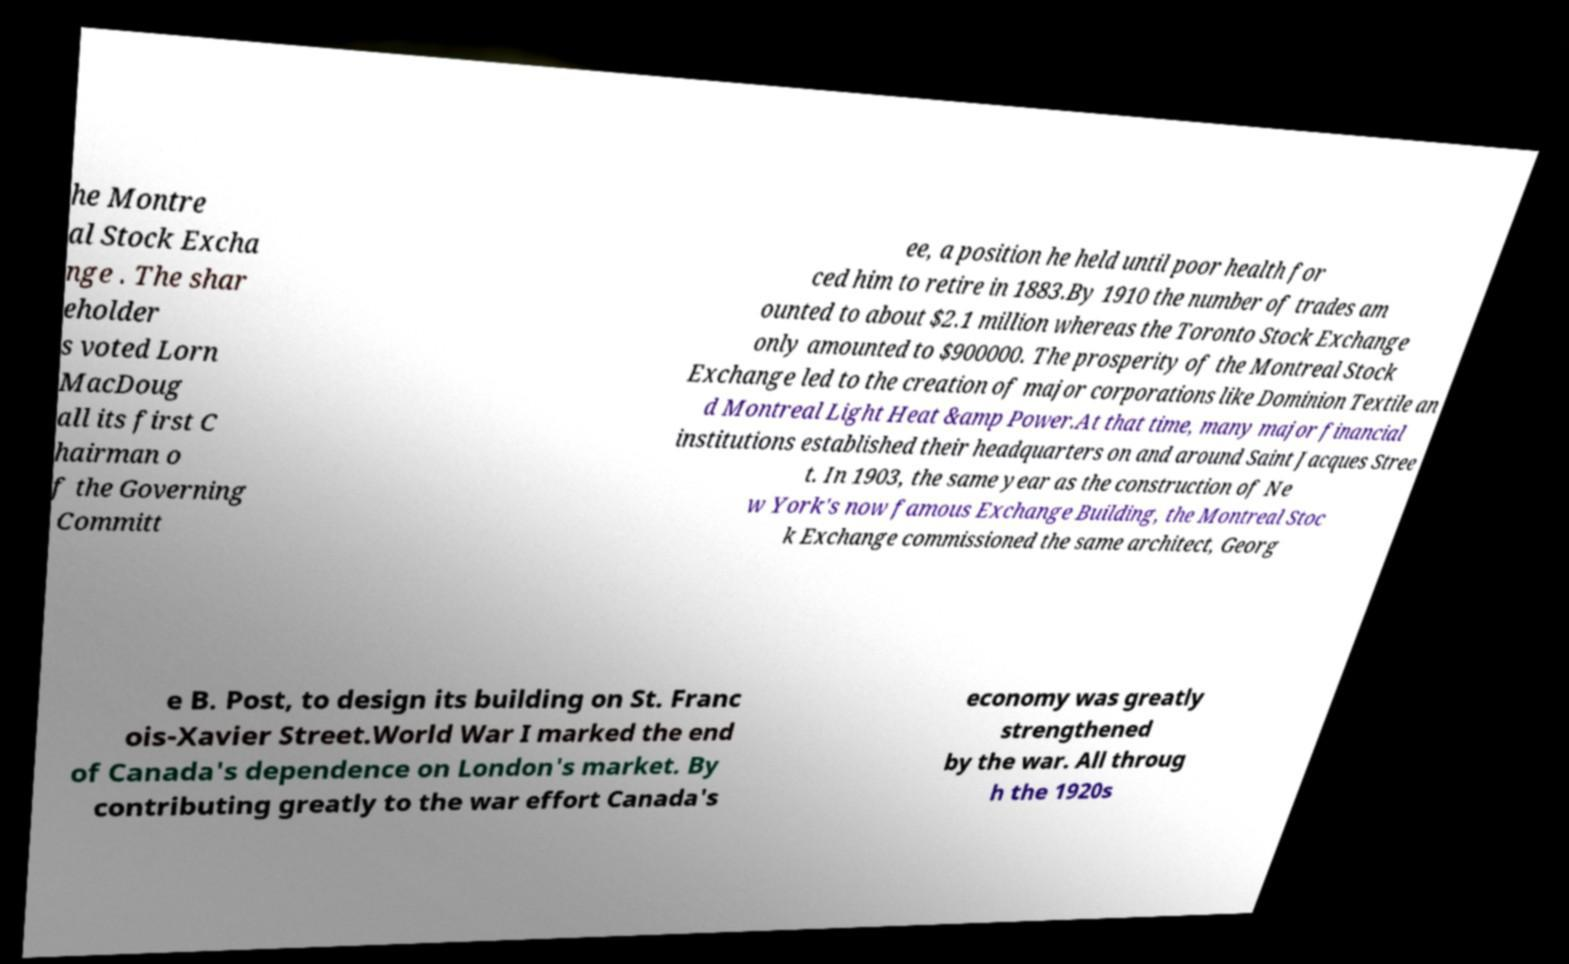I need the written content from this picture converted into text. Can you do that? he Montre al Stock Excha nge . The shar eholder s voted Lorn MacDoug all its first C hairman o f the Governing Committ ee, a position he held until poor health for ced him to retire in 1883.By 1910 the number of trades am ounted to about $2.1 million whereas the Toronto Stock Exchange only amounted to $900000. The prosperity of the Montreal Stock Exchange led to the creation of major corporations like Dominion Textile an d Montreal Light Heat &amp Power.At that time, many major financial institutions established their headquarters on and around Saint Jacques Stree t. In 1903, the same year as the construction of Ne w York's now famous Exchange Building, the Montreal Stoc k Exchange commissioned the same architect, Georg e B. Post, to design its building on St. Franc ois-Xavier Street.World War I marked the end of Canada's dependence on London's market. By contributing greatly to the war effort Canada's economy was greatly strengthened by the war. All throug h the 1920s 